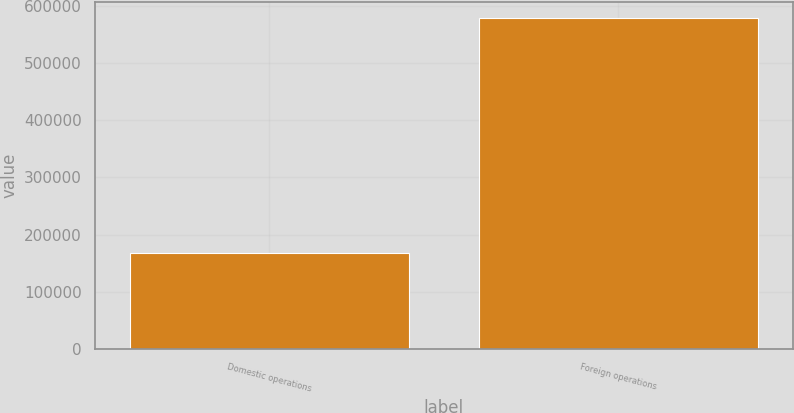Convert chart. <chart><loc_0><loc_0><loc_500><loc_500><bar_chart><fcel>Domestic operations<fcel>Foreign operations<nl><fcel>168135<fcel>579021<nl></chart> 